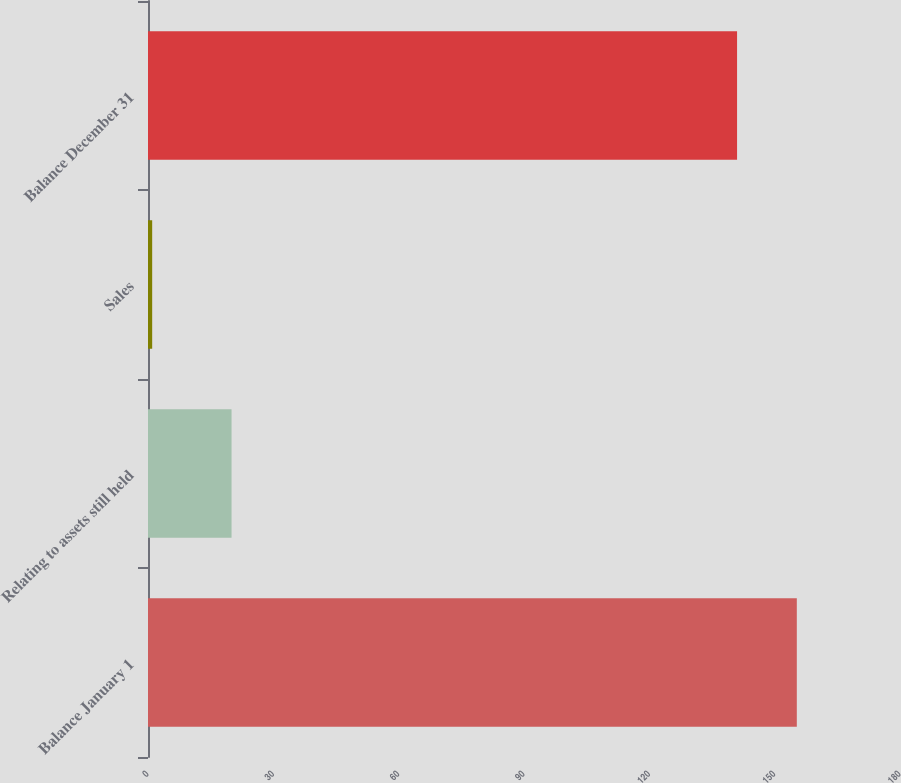Convert chart. <chart><loc_0><loc_0><loc_500><loc_500><bar_chart><fcel>Balance January 1<fcel>Relating to assets still held<fcel>Sales<fcel>Balance December 31<nl><fcel>155.3<fcel>20<fcel>1<fcel>141<nl></chart> 